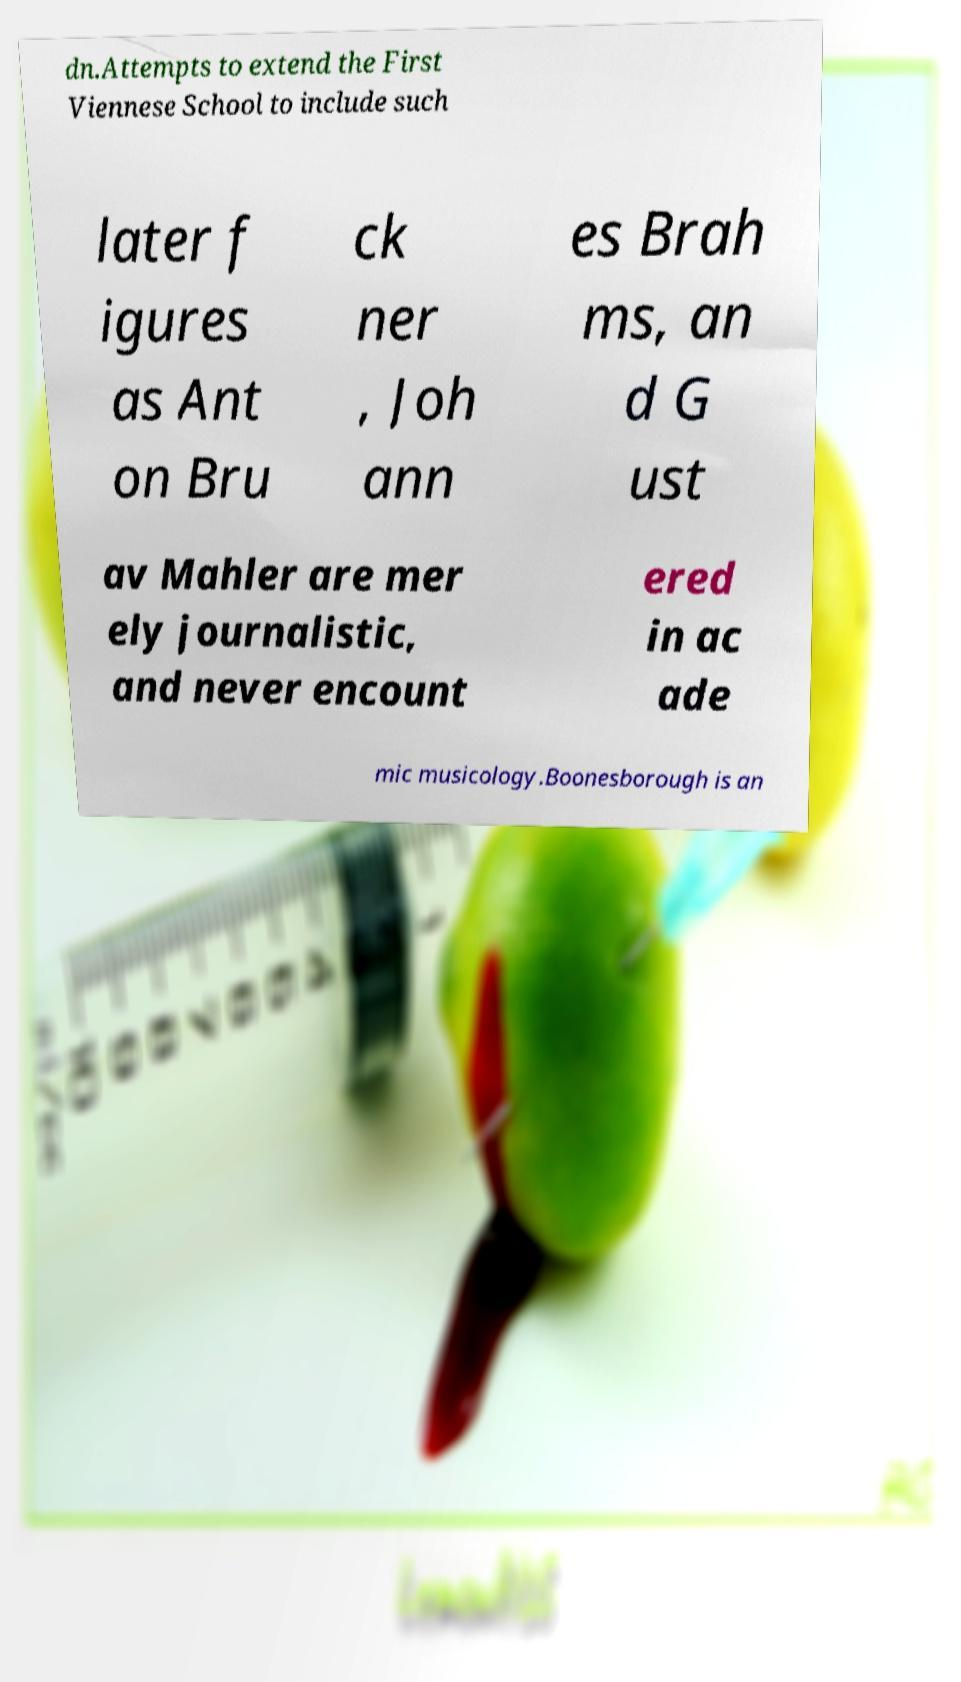Can you read and provide the text displayed in the image?This photo seems to have some interesting text. Can you extract and type it out for me? dn.Attempts to extend the First Viennese School to include such later f igures as Ant on Bru ck ner , Joh ann es Brah ms, an d G ust av Mahler are mer ely journalistic, and never encount ered in ac ade mic musicology.Boonesborough is an 